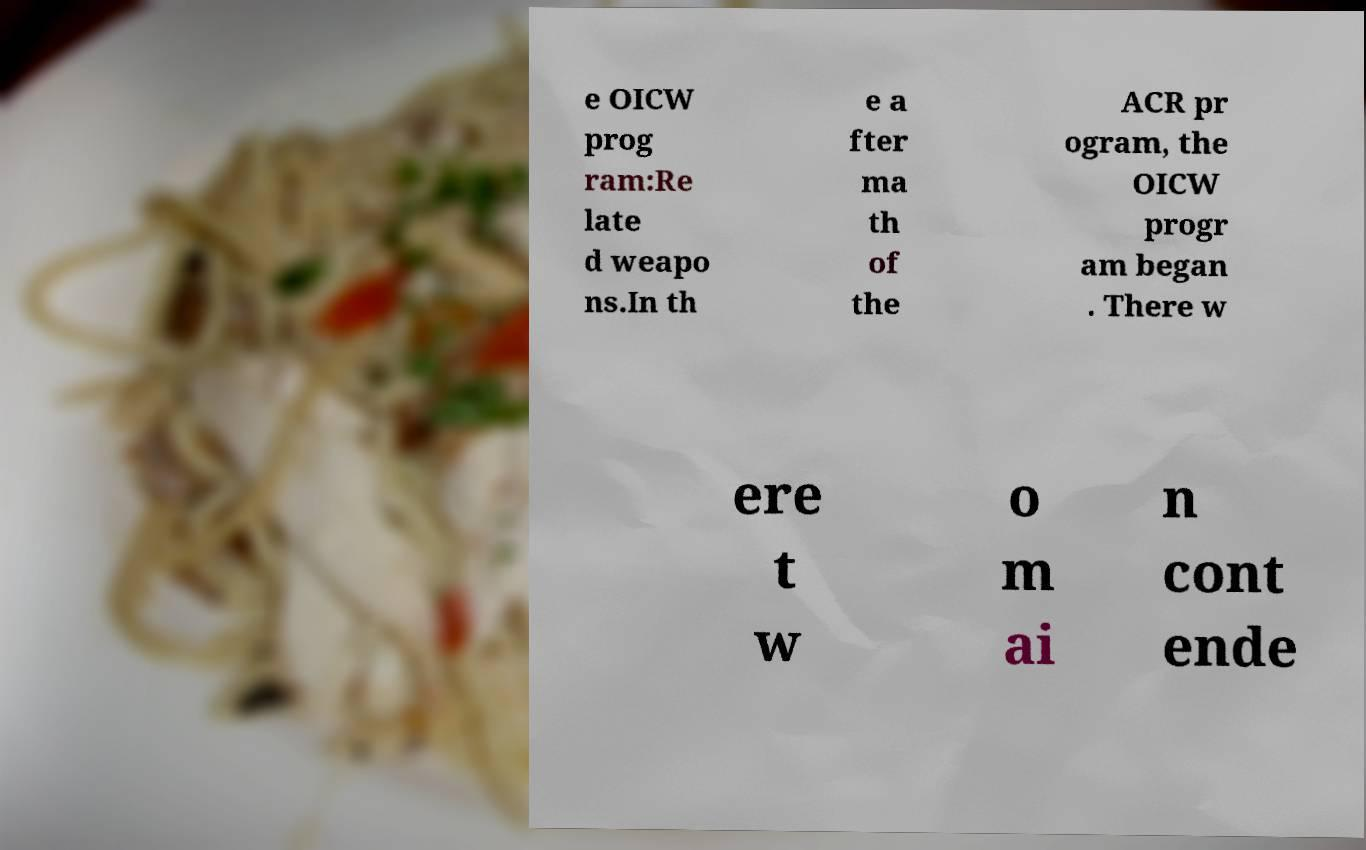Could you assist in decoding the text presented in this image and type it out clearly? e OICW prog ram:Re late d weapo ns.In th e a fter ma th of the ACR pr ogram, the OICW progr am began . There w ere t w o m ai n cont ende 